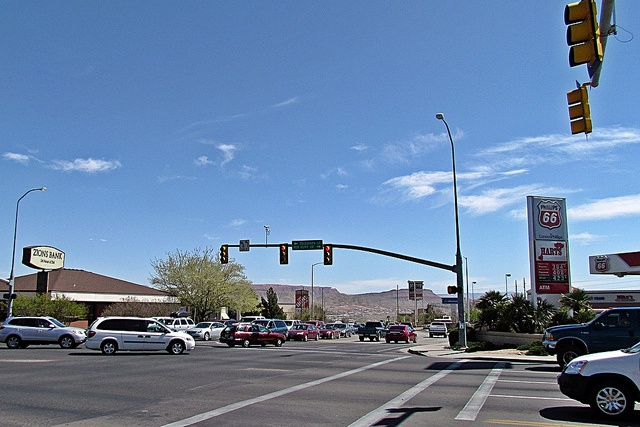Describe the objects in this image and their specific colors. I can see car in gray, black, and white tones, car in gray, black, navy, and blue tones, car in gray, black, and white tones, car in gray, black, and lavender tones, and traffic light in gray, black, maroon, olive, and navy tones in this image. 